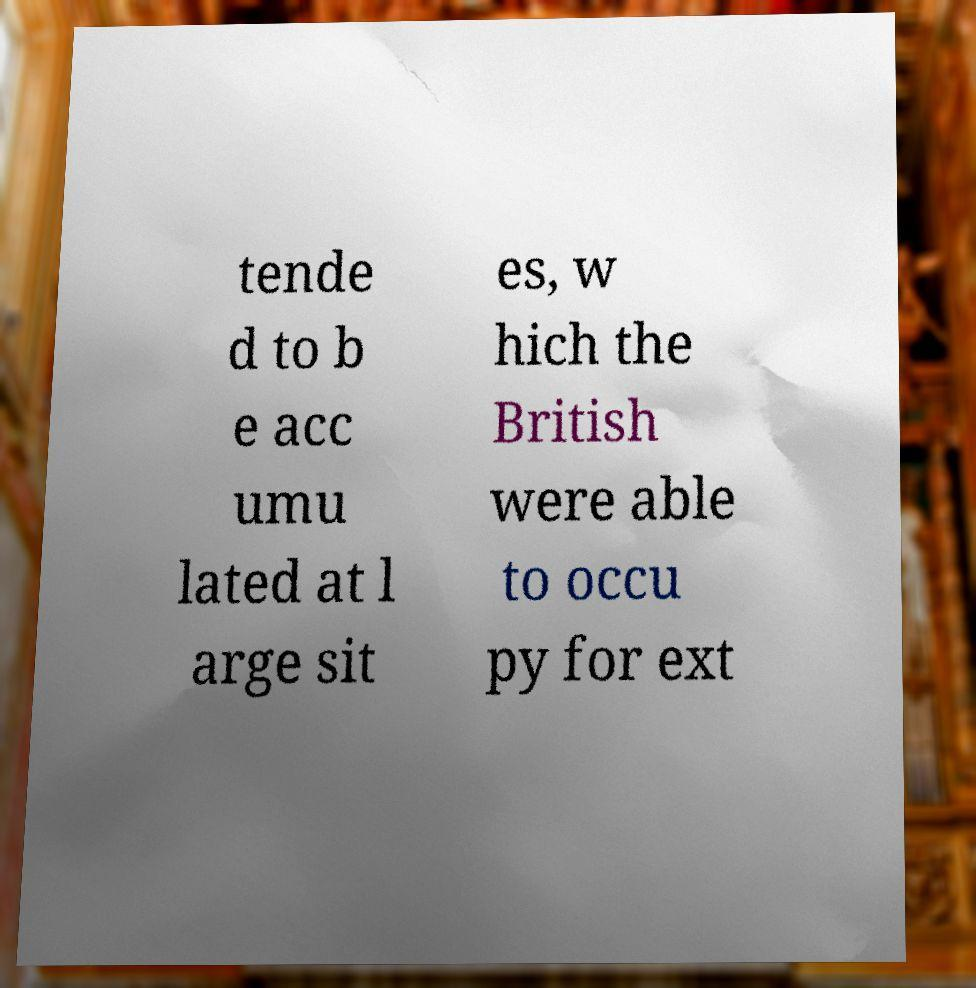Could you assist in decoding the text presented in this image and type it out clearly? tende d to b e acc umu lated at l arge sit es, w hich the British were able to occu py for ext 